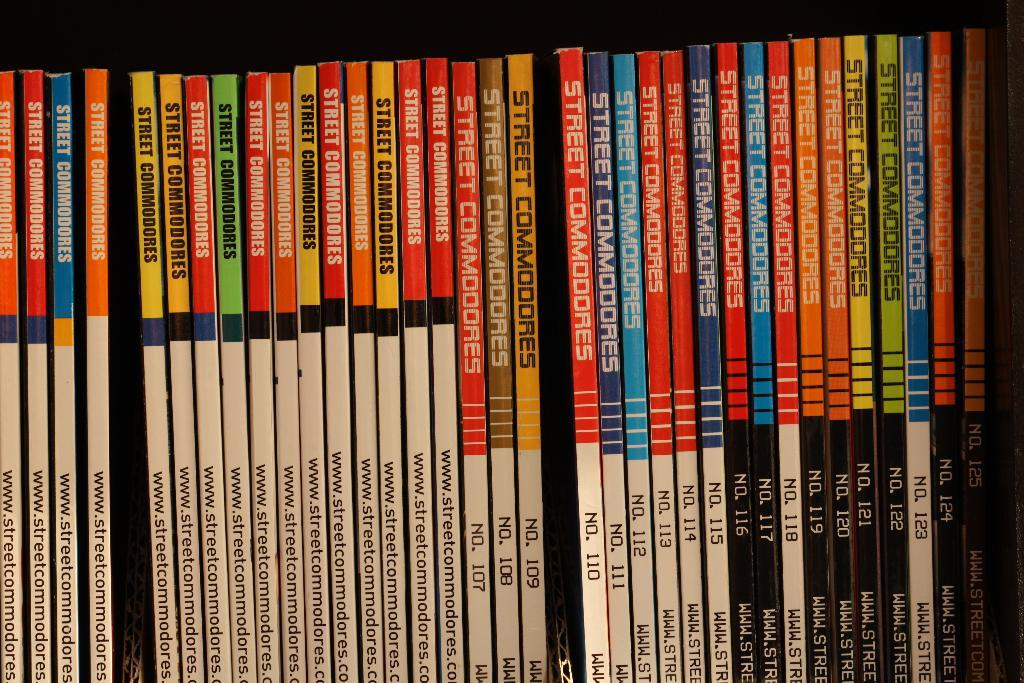<image>
Summarize the visual content of the image. a row of books with one title being 'street commodores' 